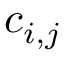<formula> <loc_0><loc_0><loc_500><loc_500>c _ { i , j }</formula> 